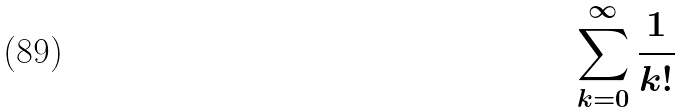<formula> <loc_0><loc_0><loc_500><loc_500>\sum _ { k = 0 } ^ { \infty } \frac { 1 } { k ! }</formula> 